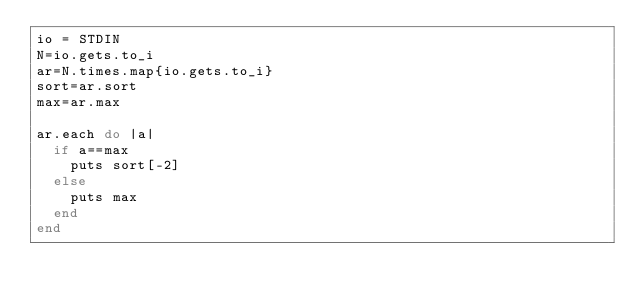Convert code to text. <code><loc_0><loc_0><loc_500><loc_500><_Ruby_>io = STDIN
N=io.gets.to_i
ar=N.times.map{io.gets.to_i}
sort=ar.sort
max=ar.max

ar.each do |a|
  if a==max
    puts sort[-2]
  else
    puts max
  end
end
</code> 